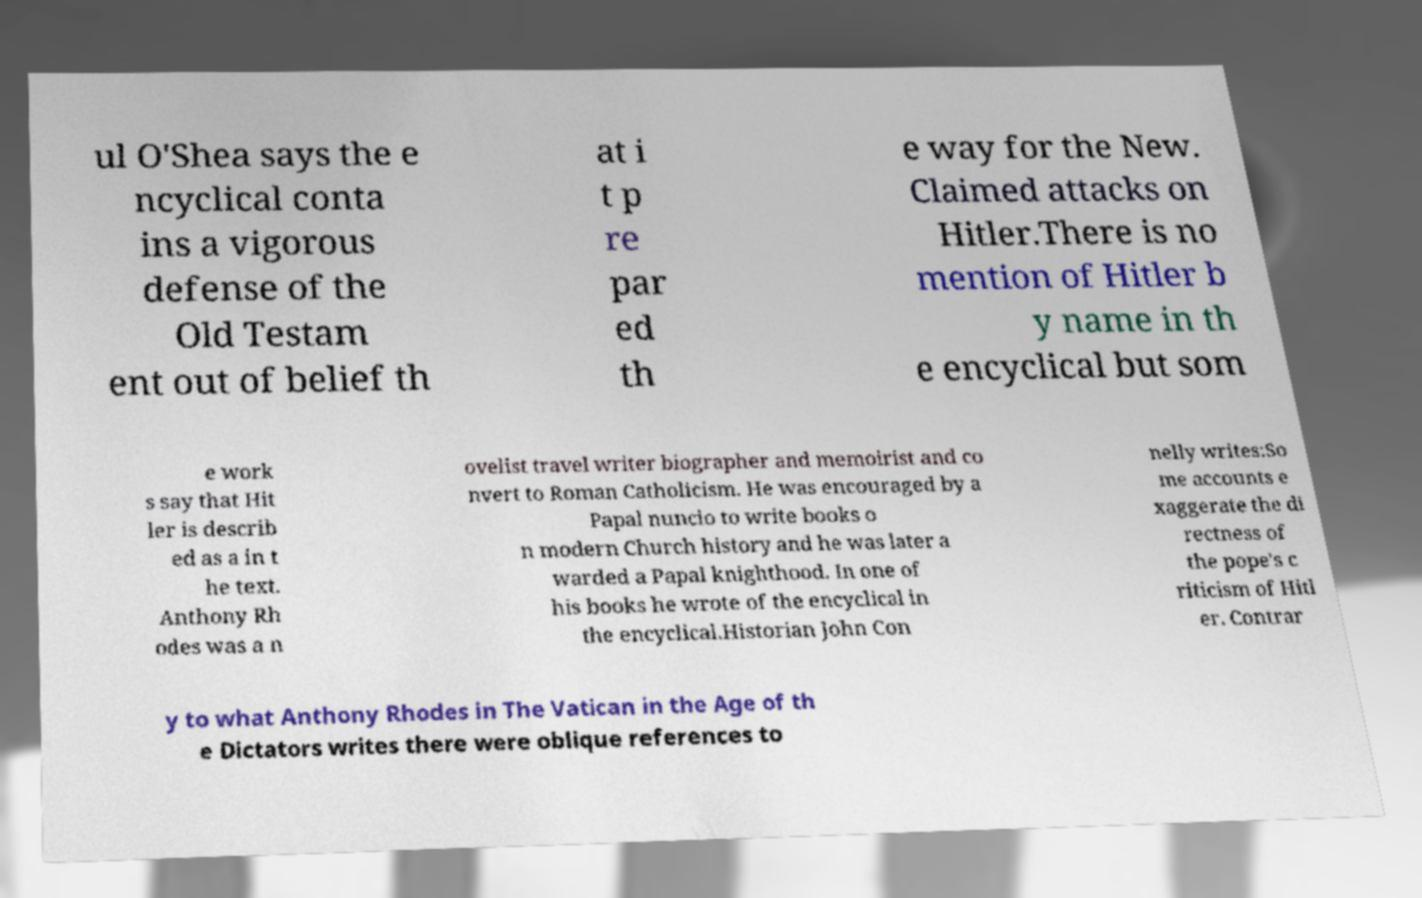What messages or text are displayed in this image? I need them in a readable, typed format. ul O'Shea says the e ncyclical conta ins a vigorous defense of the Old Testam ent out of belief th at i t p re par ed th e way for the New. Claimed attacks on Hitler.There is no mention of Hitler b y name in th e encyclical but som e work s say that Hit ler is describ ed as a in t he text. Anthony Rh odes was a n ovelist travel writer biographer and memoirist and co nvert to Roman Catholicism. He was encouraged by a Papal nuncio to write books o n modern Church history and he was later a warded a Papal knighthood. In one of his books he wrote of the encyclical in the encyclical.Historian John Con nelly writes:So me accounts e xaggerate the di rectness of the pope's c riticism of Hitl er. Contrar y to what Anthony Rhodes in The Vatican in the Age of th e Dictators writes there were oblique references to 